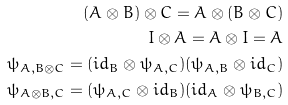Convert formula to latex. <formula><loc_0><loc_0><loc_500><loc_500>( A \otimes B ) \otimes C = A \otimes ( B \otimes C ) \\ I \otimes A = A \otimes I = A \\ \psi _ { A , B \otimes C } = ( i d _ { B } \otimes \psi _ { A , C } ) ( \psi _ { A , B } \otimes i d _ { C } ) \\ \psi _ { A \otimes B , C } = ( \psi _ { A , C } \otimes i d _ { B } ) ( i d _ { A } \otimes \psi _ { B , C } )</formula> 